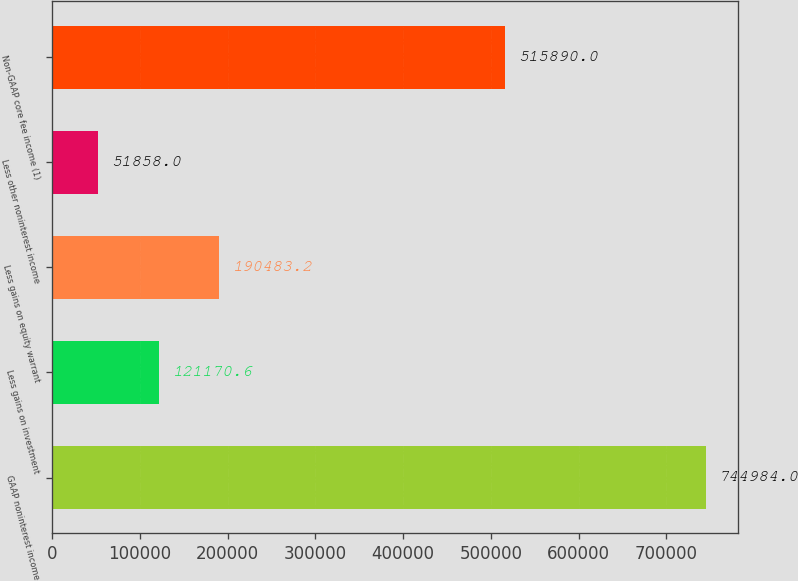Convert chart to OTSL. <chart><loc_0><loc_0><loc_500><loc_500><bar_chart><fcel>GAAP noninterest income<fcel>Less gains on investment<fcel>Less gains on equity warrant<fcel>Less other noninterest income<fcel>Non-GAAP core fee income (1)<nl><fcel>744984<fcel>121171<fcel>190483<fcel>51858<fcel>515890<nl></chart> 